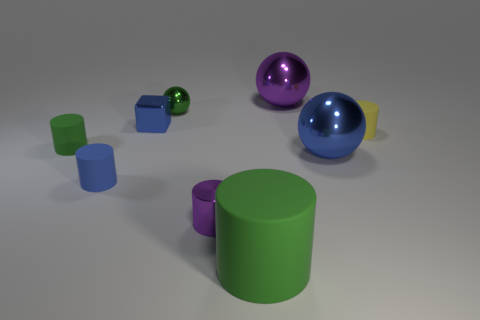Subtract all purple cylinders. How many cylinders are left? 4 Subtract all blue cylinders. How many cylinders are left? 4 Subtract all cyan cylinders. Subtract all yellow spheres. How many cylinders are left? 5 Subtract all spheres. How many objects are left? 6 Subtract 0 gray balls. How many objects are left? 9 Subtract all green matte objects. Subtract all large brown matte things. How many objects are left? 7 Add 3 small green metallic objects. How many small green metallic objects are left? 4 Add 1 tiny blue rubber things. How many tiny blue rubber things exist? 2 